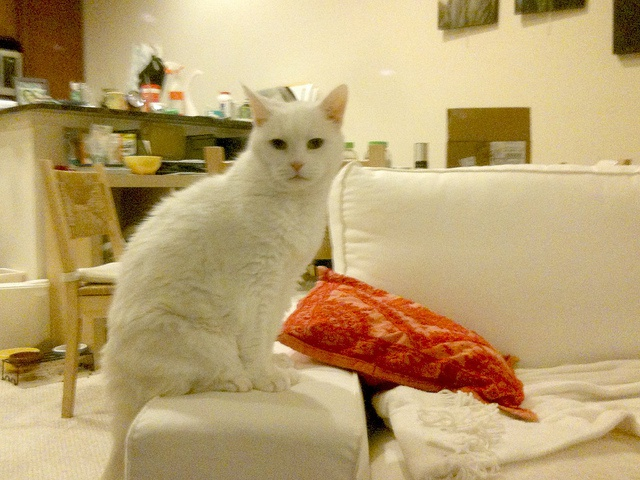Describe the objects in this image and their specific colors. I can see couch in olive and tan tones, cat in olive and tan tones, chair in olive and tan tones, dining table in olive and tan tones, and chair in olive and tan tones in this image. 